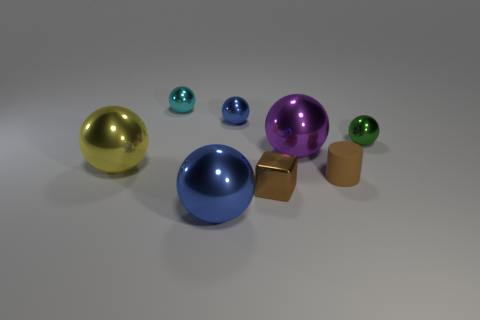There is a large sphere that is in front of the large yellow metal object; is its color the same as the tiny rubber thing?
Give a very brief answer. No. What number of blue objects have the same size as the purple sphere?
Your answer should be very brief. 1. Is there a metal sphere of the same color as the cylinder?
Offer a terse response. No. Is the material of the large yellow object the same as the purple thing?
Keep it short and to the point. Yes. What number of big blue objects are the same shape as the large purple thing?
Your answer should be compact. 1. What shape is the brown thing that is the same material as the large yellow object?
Provide a short and direct response. Cube. The tiny metallic object that is in front of the small metallic ball that is right of the cylinder is what color?
Make the answer very short. Brown. Is the color of the cylinder the same as the block?
Keep it short and to the point. Yes. The blue thing that is in front of the tiny shiny thing right of the purple metallic ball is made of what material?
Keep it short and to the point. Metal. There is a large purple thing that is the same shape as the tiny blue shiny object; what is its material?
Provide a succinct answer. Metal. 